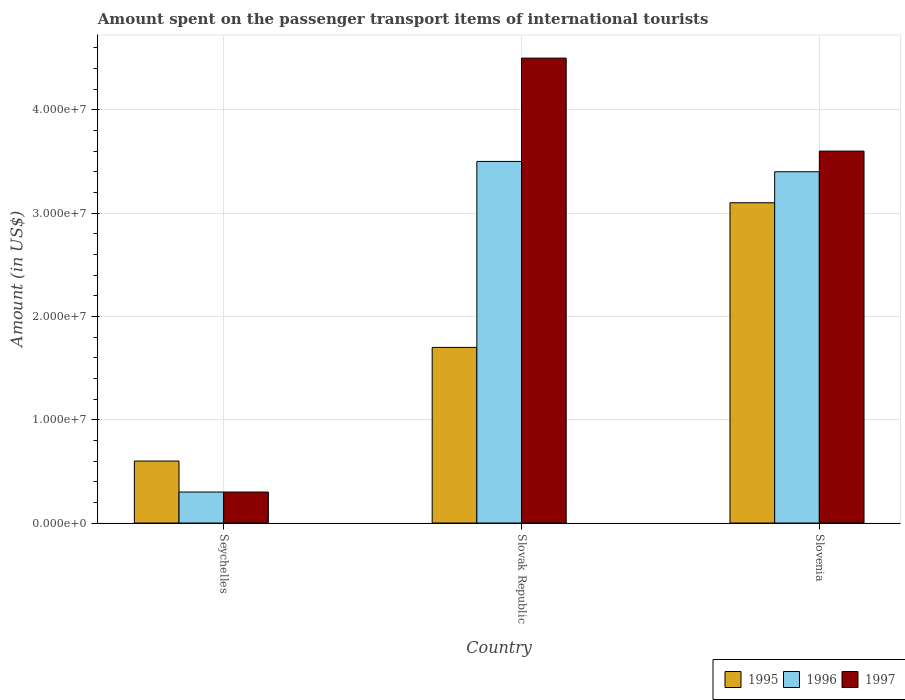How many bars are there on the 2nd tick from the left?
Give a very brief answer. 3. How many bars are there on the 2nd tick from the right?
Make the answer very short. 3. What is the label of the 2nd group of bars from the left?
Make the answer very short. Slovak Republic. What is the amount spent on the passenger transport items of international tourists in 1997 in Seychelles?
Your answer should be compact. 3.00e+06. Across all countries, what is the maximum amount spent on the passenger transport items of international tourists in 1996?
Your answer should be very brief. 3.50e+07. In which country was the amount spent on the passenger transport items of international tourists in 1997 maximum?
Make the answer very short. Slovak Republic. In which country was the amount spent on the passenger transport items of international tourists in 1996 minimum?
Your response must be concise. Seychelles. What is the total amount spent on the passenger transport items of international tourists in 1995 in the graph?
Make the answer very short. 5.40e+07. What is the difference between the amount spent on the passenger transport items of international tourists in 1995 in Slovak Republic and that in Slovenia?
Your answer should be very brief. -1.40e+07. What is the difference between the amount spent on the passenger transport items of international tourists in 1995 in Slovenia and the amount spent on the passenger transport items of international tourists in 1996 in Seychelles?
Give a very brief answer. 2.80e+07. What is the average amount spent on the passenger transport items of international tourists in 1995 per country?
Offer a terse response. 1.80e+07. In how many countries, is the amount spent on the passenger transport items of international tourists in 1995 greater than 16000000 US$?
Your answer should be very brief. 2. What is the ratio of the amount spent on the passenger transport items of international tourists in 1996 in Slovak Republic to that in Slovenia?
Offer a very short reply. 1.03. Is the difference between the amount spent on the passenger transport items of international tourists in 1997 in Slovak Republic and Slovenia greater than the difference between the amount spent on the passenger transport items of international tourists in 1995 in Slovak Republic and Slovenia?
Keep it short and to the point. Yes. What is the difference between the highest and the second highest amount spent on the passenger transport items of international tourists in 1997?
Ensure brevity in your answer.  9.00e+06. What is the difference between the highest and the lowest amount spent on the passenger transport items of international tourists in 1996?
Your response must be concise. 3.20e+07. Is the sum of the amount spent on the passenger transport items of international tourists in 1995 in Slovak Republic and Slovenia greater than the maximum amount spent on the passenger transport items of international tourists in 1996 across all countries?
Your answer should be very brief. Yes. What does the 3rd bar from the right in Slovak Republic represents?
Provide a short and direct response. 1995. Is it the case that in every country, the sum of the amount spent on the passenger transport items of international tourists in 1996 and amount spent on the passenger transport items of international tourists in 1997 is greater than the amount spent on the passenger transport items of international tourists in 1995?
Make the answer very short. No. Are all the bars in the graph horizontal?
Keep it short and to the point. No. Are the values on the major ticks of Y-axis written in scientific E-notation?
Your answer should be compact. Yes. Does the graph contain any zero values?
Provide a short and direct response. No. Does the graph contain grids?
Your answer should be very brief. Yes. How many legend labels are there?
Provide a short and direct response. 3. How are the legend labels stacked?
Your answer should be very brief. Horizontal. What is the title of the graph?
Your answer should be very brief. Amount spent on the passenger transport items of international tourists. What is the Amount (in US$) of 1996 in Seychelles?
Your answer should be very brief. 3.00e+06. What is the Amount (in US$) of 1995 in Slovak Republic?
Keep it short and to the point. 1.70e+07. What is the Amount (in US$) of 1996 in Slovak Republic?
Offer a terse response. 3.50e+07. What is the Amount (in US$) in 1997 in Slovak Republic?
Your answer should be very brief. 4.50e+07. What is the Amount (in US$) in 1995 in Slovenia?
Provide a succinct answer. 3.10e+07. What is the Amount (in US$) in 1996 in Slovenia?
Give a very brief answer. 3.40e+07. What is the Amount (in US$) in 1997 in Slovenia?
Offer a terse response. 3.60e+07. Across all countries, what is the maximum Amount (in US$) of 1995?
Offer a terse response. 3.10e+07. Across all countries, what is the maximum Amount (in US$) of 1996?
Your response must be concise. 3.50e+07. Across all countries, what is the maximum Amount (in US$) in 1997?
Offer a very short reply. 4.50e+07. Across all countries, what is the minimum Amount (in US$) of 1996?
Your answer should be compact. 3.00e+06. What is the total Amount (in US$) in 1995 in the graph?
Your answer should be compact. 5.40e+07. What is the total Amount (in US$) in 1996 in the graph?
Your response must be concise. 7.20e+07. What is the total Amount (in US$) in 1997 in the graph?
Provide a succinct answer. 8.40e+07. What is the difference between the Amount (in US$) of 1995 in Seychelles and that in Slovak Republic?
Give a very brief answer. -1.10e+07. What is the difference between the Amount (in US$) of 1996 in Seychelles and that in Slovak Republic?
Offer a terse response. -3.20e+07. What is the difference between the Amount (in US$) of 1997 in Seychelles and that in Slovak Republic?
Give a very brief answer. -4.20e+07. What is the difference between the Amount (in US$) in 1995 in Seychelles and that in Slovenia?
Ensure brevity in your answer.  -2.50e+07. What is the difference between the Amount (in US$) of 1996 in Seychelles and that in Slovenia?
Offer a terse response. -3.10e+07. What is the difference between the Amount (in US$) of 1997 in Seychelles and that in Slovenia?
Provide a succinct answer. -3.30e+07. What is the difference between the Amount (in US$) of 1995 in Slovak Republic and that in Slovenia?
Keep it short and to the point. -1.40e+07. What is the difference between the Amount (in US$) in 1997 in Slovak Republic and that in Slovenia?
Your response must be concise. 9.00e+06. What is the difference between the Amount (in US$) in 1995 in Seychelles and the Amount (in US$) in 1996 in Slovak Republic?
Provide a succinct answer. -2.90e+07. What is the difference between the Amount (in US$) in 1995 in Seychelles and the Amount (in US$) in 1997 in Slovak Republic?
Provide a short and direct response. -3.90e+07. What is the difference between the Amount (in US$) of 1996 in Seychelles and the Amount (in US$) of 1997 in Slovak Republic?
Your response must be concise. -4.20e+07. What is the difference between the Amount (in US$) of 1995 in Seychelles and the Amount (in US$) of 1996 in Slovenia?
Offer a very short reply. -2.80e+07. What is the difference between the Amount (in US$) of 1995 in Seychelles and the Amount (in US$) of 1997 in Slovenia?
Your answer should be very brief. -3.00e+07. What is the difference between the Amount (in US$) of 1996 in Seychelles and the Amount (in US$) of 1997 in Slovenia?
Offer a very short reply. -3.30e+07. What is the difference between the Amount (in US$) of 1995 in Slovak Republic and the Amount (in US$) of 1996 in Slovenia?
Offer a terse response. -1.70e+07. What is the difference between the Amount (in US$) in 1995 in Slovak Republic and the Amount (in US$) in 1997 in Slovenia?
Your answer should be compact. -1.90e+07. What is the average Amount (in US$) of 1995 per country?
Your response must be concise. 1.80e+07. What is the average Amount (in US$) of 1996 per country?
Your answer should be compact. 2.40e+07. What is the average Amount (in US$) of 1997 per country?
Offer a terse response. 2.80e+07. What is the difference between the Amount (in US$) of 1995 and Amount (in US$) of 1997 in Seychelles?
Your answer should be very brief. 3.00e+06. What is the difference between the Amount (in US$) in 1996 and Amount (in US$) in 1997 in Seychelles?
Provide a short and direct response. 0. What is the difference between the Amount (in US$) of 1995 and Amount (in US$) of 1996 in Slovak Republic?
Give a very brief answer. -1.80e+07. What is the difference between the Amount (in US$) of 1995 and Amount (in US$) of 1997 in Slovak Republic?
Provide a succinct answer. -2.80e+07. What is the difference between the Amount (in US$) in 1996 and Amount (in US$) in 1997 in Slovak Republic?
Offer a terse response. -1.00e+07. What is the difference between the Amount (in US$) in 1995 and Amount (in US$) in 1996 in Slovenia?
Give a very brief answer. -3.00e+06. What is the difference between the Amount (in US$) of 1995 and Amount (in US$) of 1997 in Slovenia?
Your answer should be compact. -5.00e+06. What is the difference between the Amount (in US$) in 1996 and Amount (in US$) in 1997 in Slovenia?
Provide a succinct answer. -2.00e+06. What is the ratio of the Amount (in US$) of 1995 in Seychelles to that in Slovak Republic?
Keep it short and to the point. 0.35. What is the ratio of the Amount (in US$) of 1996 in Seychelles to that in Slovak Republic?
Your response must be concise. 0.09. What is the ratio of the Amount (in US$) in 1997 in Seychelles to that in Slovak Republic?
Your response must be concise. 0.07. What is the ratio of the Amount (in US$) in 1995 in Seychelles to that in Slovenia?
Your answer should be very brief. 0.19. What is the ratio of the Amount (in US$) of 1996 in Seychelles to that in Slovenia?
Your response must be concise. 0.09. What is the ratio of the Amount (in US$) of 1997 in Seychelles to that in Slovenia?
Provide a short and direct response. 0.08. What is the ratio of the Amount (in US$) of 1995 in Slovak Republic to that in Slovenia?
Make the answer very short. 0.55. What is the ratio of the Amount (in US$) of 1996 in Slovak Republic to that in Slovenia?
Provide a succinct answer. 1.03. What is the ratio of the Amount (in US$) of 1997 in Slovak Republic to that in Slovenia?
Give a very brief answer. 1.25. What is the difference between the highest and the second highest Amount (in US$) in 1995?
Make the answer very short. 1.40e+07. What is the difference between the highest and the second highest Amount (in US$) in 1997?
Offer a terse response. 9.00e+06. What is the difference between the highest and the lowest Amount (in US$) in 1995?
Give a very brief answer. 2.50e+07. What is the difference between the highest and the lowest Amount (in US$) of 1996?
Your answer should be compact. 3.20e+07. What is the difference between the highest and the lowest Amount (in US$) of 1997?
Offer a very short reply. 4.20e+07. 